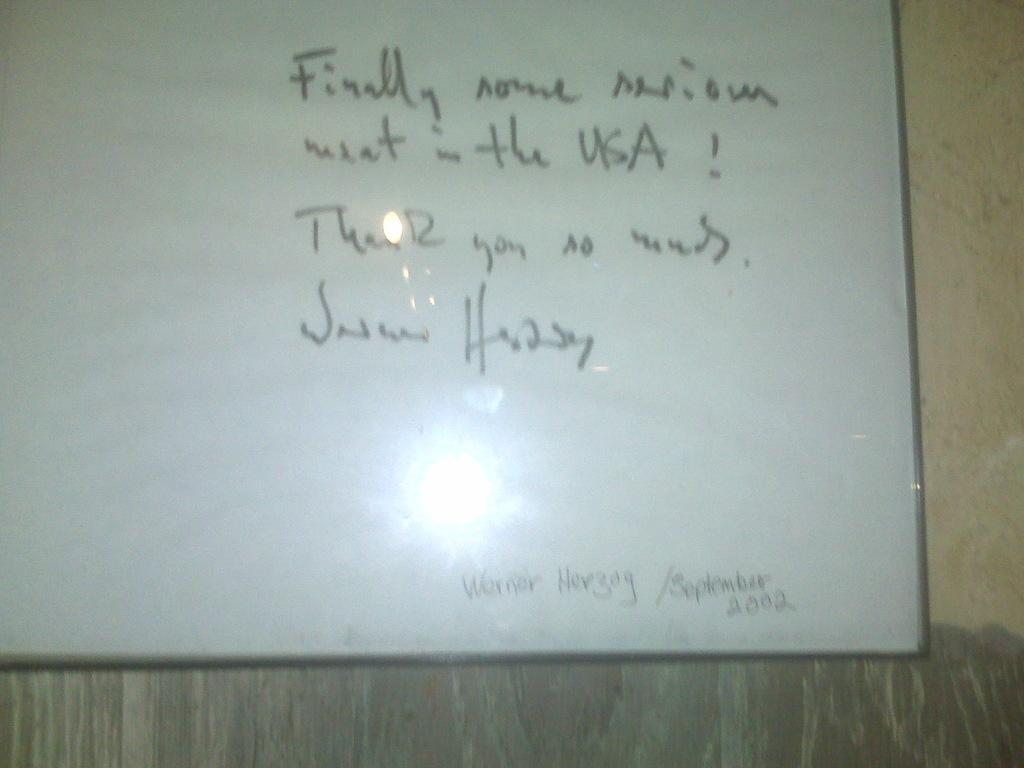<image>
Render a clear and concise summary of the photo. A quote by Werner Herzog is written on the whiteboard. 